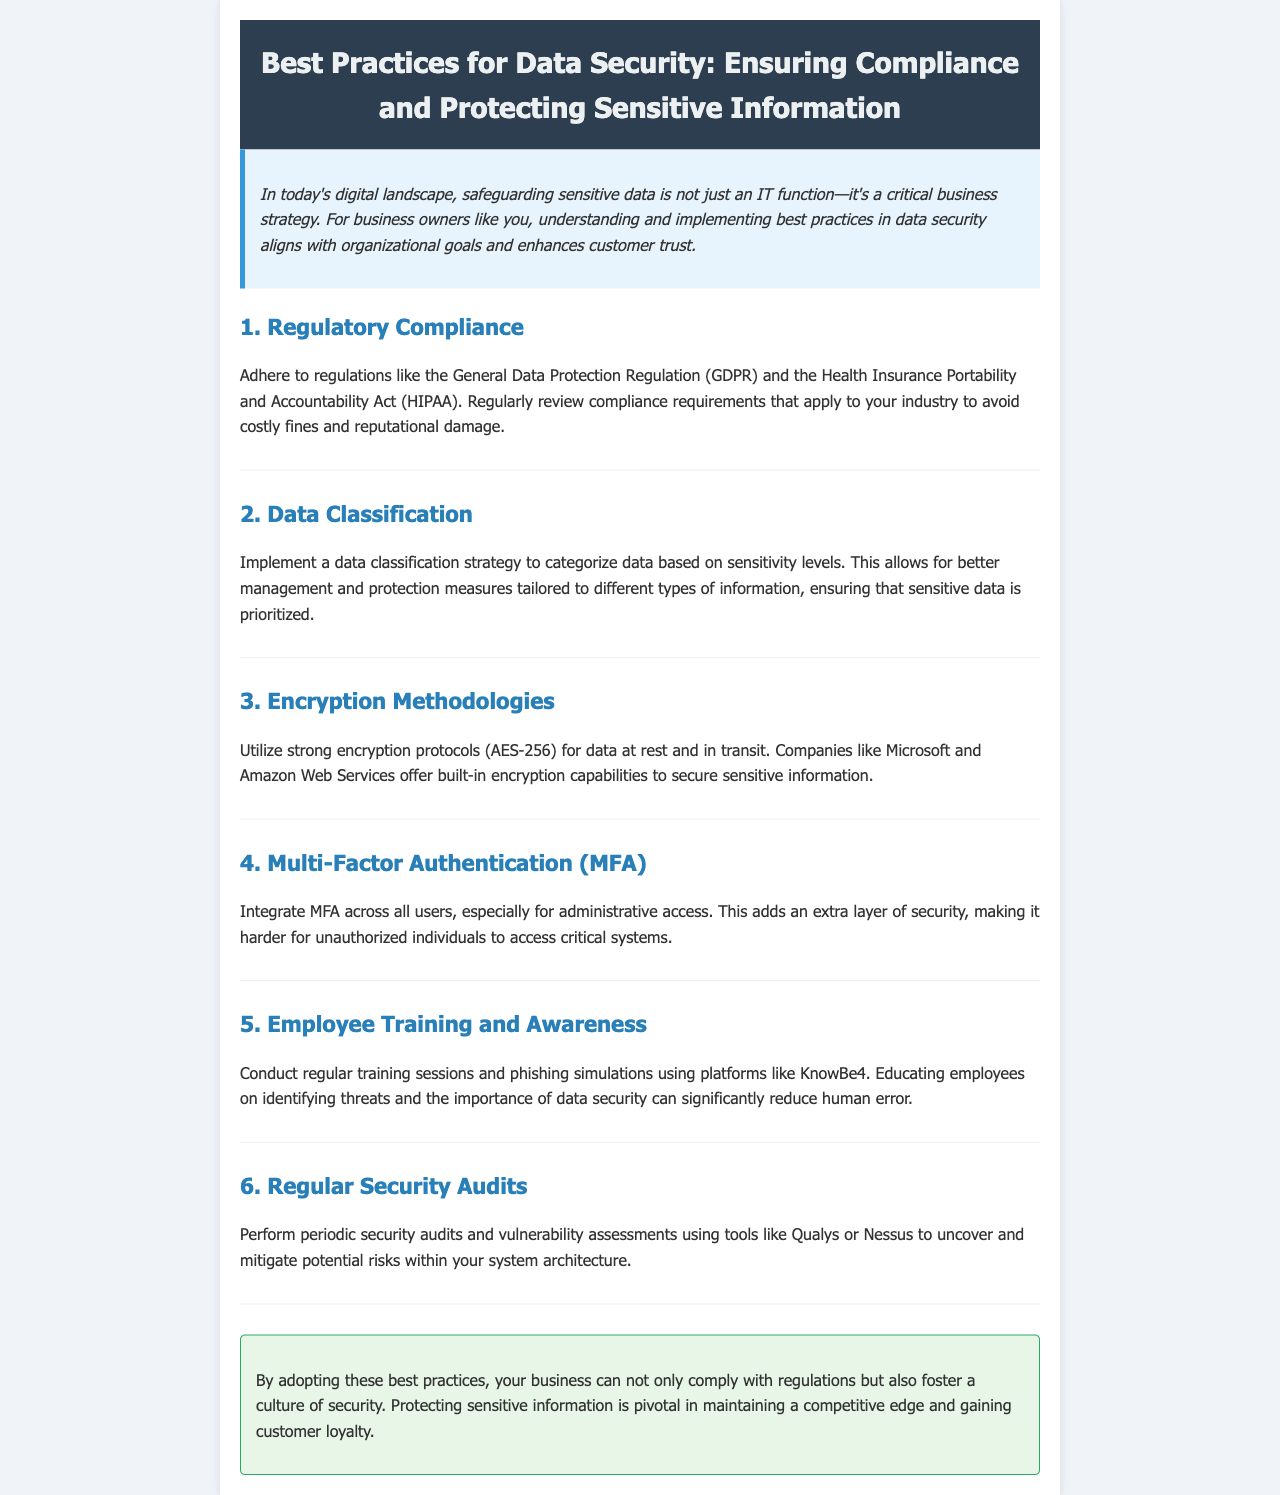What is the main purpose of the newsletter? The introduction states that safeguarding sensitive data is a critical business strategy for business owners.
Answer: Safeguarding sensitive data Which regulation is mentioned as a compliance requirement? The section on Regulatory Compliance specifically mentions the General Data Protection Regulation (GDPR).
Answer: GDPR What encryption standard is recommended in the document? The section on Encryption Methodologies mentions AES-256 as a strong encryption protocol.
Answer: AES-256 How often should security audits be performed? The section on Regular Security Audits implies periodic audits but does not specify a frequency.
Answer: Periodic What type of training is suggested for employees? The section on Employee Training and Awareness suggests conducting regular training sessions and phishing simulations.
Answer: Regular training sessions and phishing simulations What is one tool mentioned for vulnerability assessments? The section on Regular Security Audits lists Qualys as one of the tools used for vulnerability assessments.
Answer: Qualys 